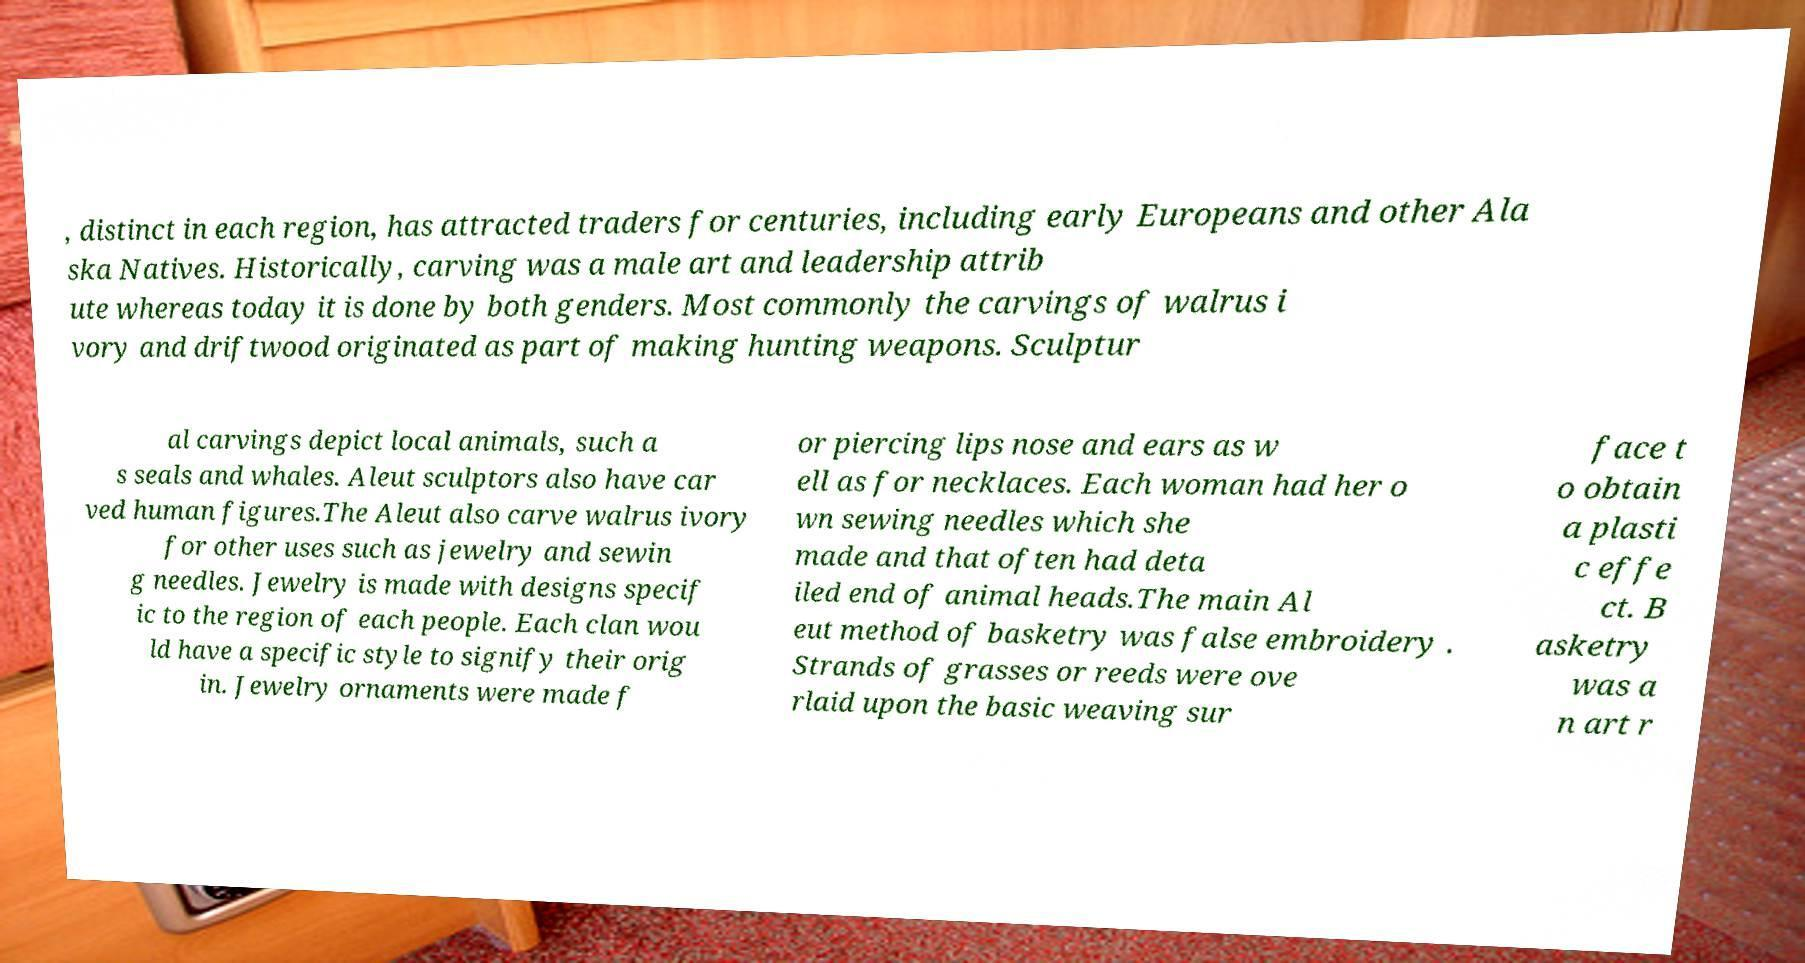Could you extract and type out the text from this image? , distinct in each region, has attracted traders for centuries, including early Europeans and other Ala ska Natives. Historically, carving was a male art and leadership attrib ute whereas today it is done by both genders. Most commonly the carvings of walrus i vory and driftwood originated as part of making hunting weapons. Sculptur al carvings depict local animals, such a s seals and whales. Aleut sculptors also have car ved human figures.The Aleut also carve walrus ivory for other uses such as jewelry and sewin g needles. Jewelry is made with designs specif ic to the region of each people. Each clan wou ld have a specific style to signify their orig in. Jewelry ornaments were made f or piercing lips nose and ears as w ell as for necklaces. Each woman had her o wn sewing needles which she made and that often had deta iled end of animal heads.The main Al eut method of basketry was false embroidery . Strands of grasses or reeds were ove rlaid upon the basic weaving sur face t o obtain a plasti c effe ct. B asketry was a n art r 